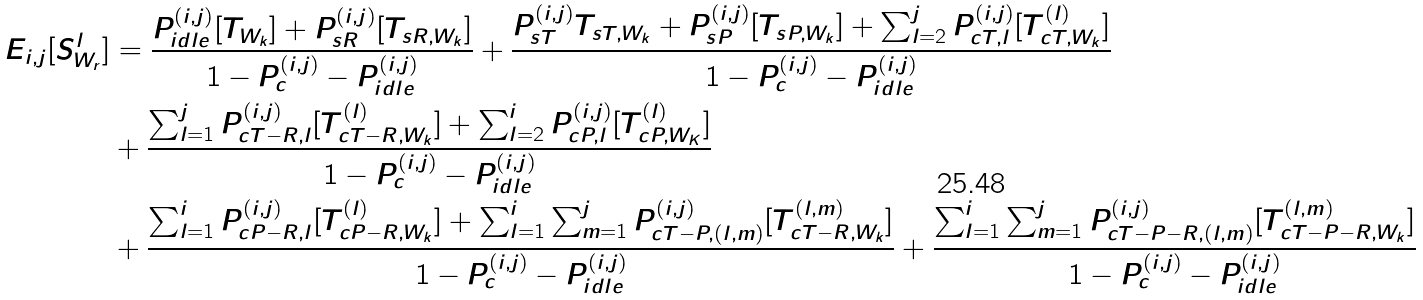<formula> <loc_0><loc_0><loc_500><loc_500>E _ { i , j } [ S _ { W _ { r } } ^ { l } ] & = \frac { P _ { i d l e } ^ { ( i , j ) } [ T _ { W _ { k } } ] + P _ { s R } ^ { ( i , j ) } [ T _ { s R , W _ { k } } ] } { 1 - P _ { c } ^ { ( i , j ) } - P _ { i d l e } ^ { ( i , j ) } } + \frac { P _ { s T } ^ { ( i , j ) } T _ { s T , W _ { k } } + P _ { s P } ^ { ( i , j ) } [ T _ { s P , W _ { k } } ] + \sum _ { l = 2 } ^ { j } P _ { c T , l } ^ { ( i , j ) } [ T _ { c T , W _ { k } } ^ { ( l ) } ] } { 1 - P _ { c } ^ { ( i , j ) } - P _ { i d l e } ^ { ( i , j ) } } \\ & + \frac { \sum _ { l = 1 } ^ { j } P _ { c T - R , l } ^ { ( i , j ) } [ T _ { c T - R , W _ { k } } ^ { ( l ) } ] + \sum _ { l = 2 } ^ { i } P _ { c P , l } ^ { ( i , j ) } [ T _ { c P , W _ { K } } ^ { ( l ) } ] } { 1 - P _ { c } ^ { ( i , j ) } - P _ { i d l e } ^ { ( i , j ) } } \\ & + \frac { \sum _ { l = 1 } ^ { i } P _ { c P - R , l } ^ { ( i , j ) } [ T _ { c P - R , W _ { k } } ^ { ( l ) } ] + \sum _ { l = 1 } ^ { i } \sum _ { m = 1 } ^ { j } P _ { c T - P , ( l , m ) } ^ { ( i , j ) } [ T _ { c T - R , W _ { k } } ^ { ( l , m ) } ] } { 1 - P _ { c } ^ { ( i , j ) } - P _ { i d l e } ^ { ( i , j ) } } + \frac { \sum _ { l = 1 } ^ { i } \sum _ { m = 1 } ^ { j } P _ { c T - P - R , ( l , m ) } ^ { ( i , j ) } [ T _ { c T - P - R , W _ { k } } ^ { ( l , m ) } ] } { 1 - P _ { c } ^ { ( i , j ) } - P _ { i d l e } ^ { ( i , j ) } }</formula> 